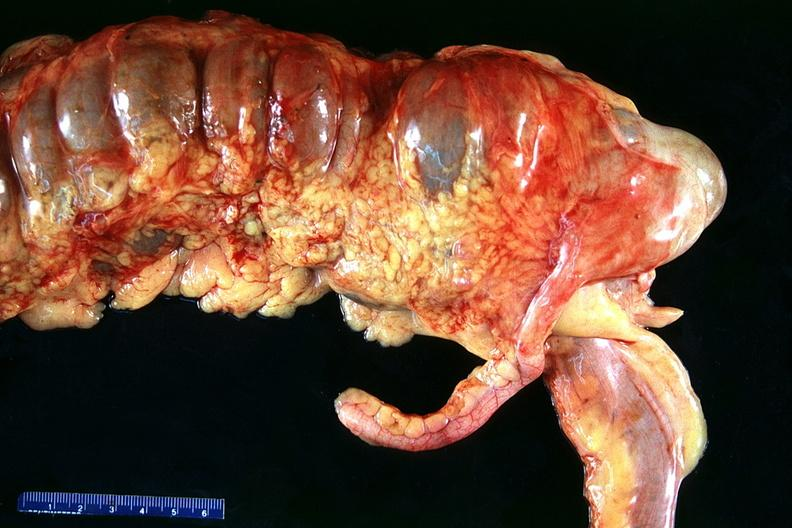does this image show normal appendix?
Answer the question using a single word or phrase. Yes 